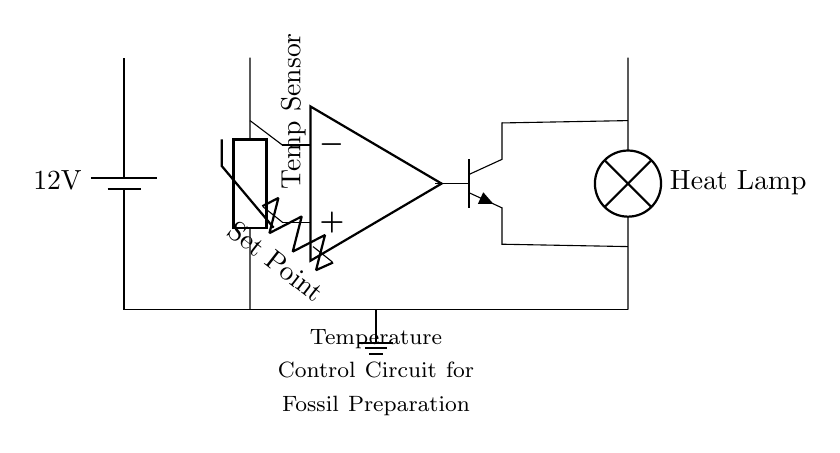What type of voltage source is used in this circuit? The circuit uses a battery as the voltage source, which is indicated by the symbol at the beginning of the diagram.
Answer: battery What is the function of the thermistor in this circuit? The thermistor acts as a temperature sensor, measuring the ambient temperature to provide feedback for regulating the heat lamp.
Answer: temperature sensor What is the role of the op-amp in the temperature control circuit? The op-amp compares the voltage from the thermistor to the set point voltage to control the transistor, thus regulating the heat lamp's operation.
Answer: comparator How many major components are in this circuit diagram? The circuit contains four major components: the battery, thermistor, op-amp, and transistor, all of which play key roles in the temperature control function.
Answer: four What is the purpose of the heat lamp in this circuit? The heat lamp serves as the heating element for the fossil preparation area, which is activated based on the temperature input from the thermistor.
Answer: heating element How is the transistor connected in the circuit? The transistor is configured with its base connected to the output of the op-amp, allowing it to act as a switch for controlling the lamp based on the op-amp's output signal.
Answer: as a switch 